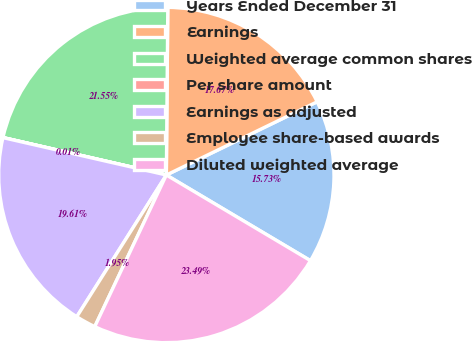Convert chart to OTSL. <chart><loc_0><loc_0><loc_500><loc_500><pie_chart><fcel>Years Ended December 31<fcel>Earnings<fcel>Weighted average common shares<fcel>Per share amount<fcel>Earnings as adjusted<fcel>Employee share-based awards<fcel>Diluted weighted average<nl><fcel>15.73%<fcel>17.67%<fcel>21.55%<fcel>0.01%<fcel>19.61%<fcel>1.95%<fcel>23.49%<nl></chart> 